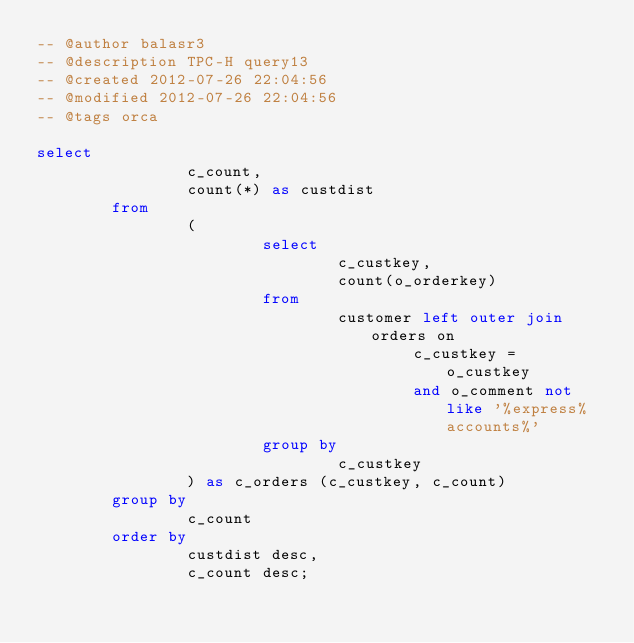Convert code to text. <code><loc_0><loc_0><loc_500><loc_500><_SQL_>-- @author balasr3
-- @description TPC-H query13
-- @created 2012-07-26 22:04:56
-- @modified 2012-07-26 22:04:56
-- @tags orca

select
                c_count,
                count(*) as custdist
        from
                (
                        select
                                c_custkey,
                                count(o_orderkey)
                        from
                                customer left outer join orders on
                                        c_custkey = o_custkey
                                        and o_comment not like '%express%accounts%'
                        group by
                                c_custkey
                ) as c_orders (c_custkey, c_count)
        group by
                c_count
        order by
                custdist desc,
                c_count desc;
</code> 